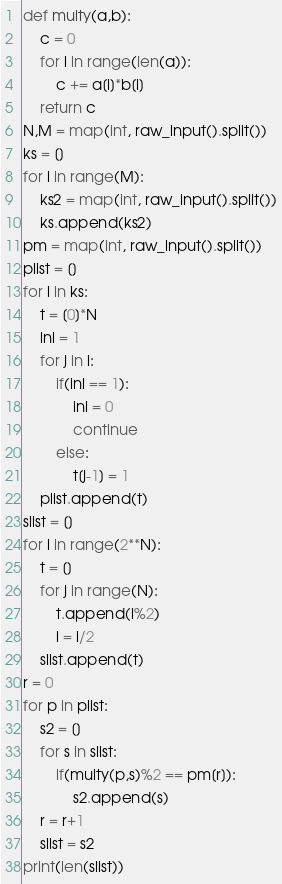<code> <loc_0><loc_0><loc_500><loc_500><_Python_>def multy(a,b):
	c = 0
	for i in range(len(a)):
		c += a[i]*b[i]
	return c
N,M = map(int, raw_input().split())
ks = []
for i in range(M):
	ks2 = map(int, raw_input().split())
	ks.append(ks2)
pm = map(int, raw_input().split())
plist = []
for i in ks:
	t = [0]*N
	ini = 1
	for j in i:
		if(ini == 1):
			ini = 0
			continue
		else:
			t[j-1] = 1
	plist.append(t)
slist = []
for i in range(2**N):
	t = []
	for j in range(N):
		t.append(i%2)
		i = i/2
	slist.append(t)
r = 0
for p in plist:
	s2 = []
	for s in slist:
		if(multy(p,s)%2 == pm[r]):
			s2.append(s)
	r = r+1
	slist = s2
print(len(slist))</code> 